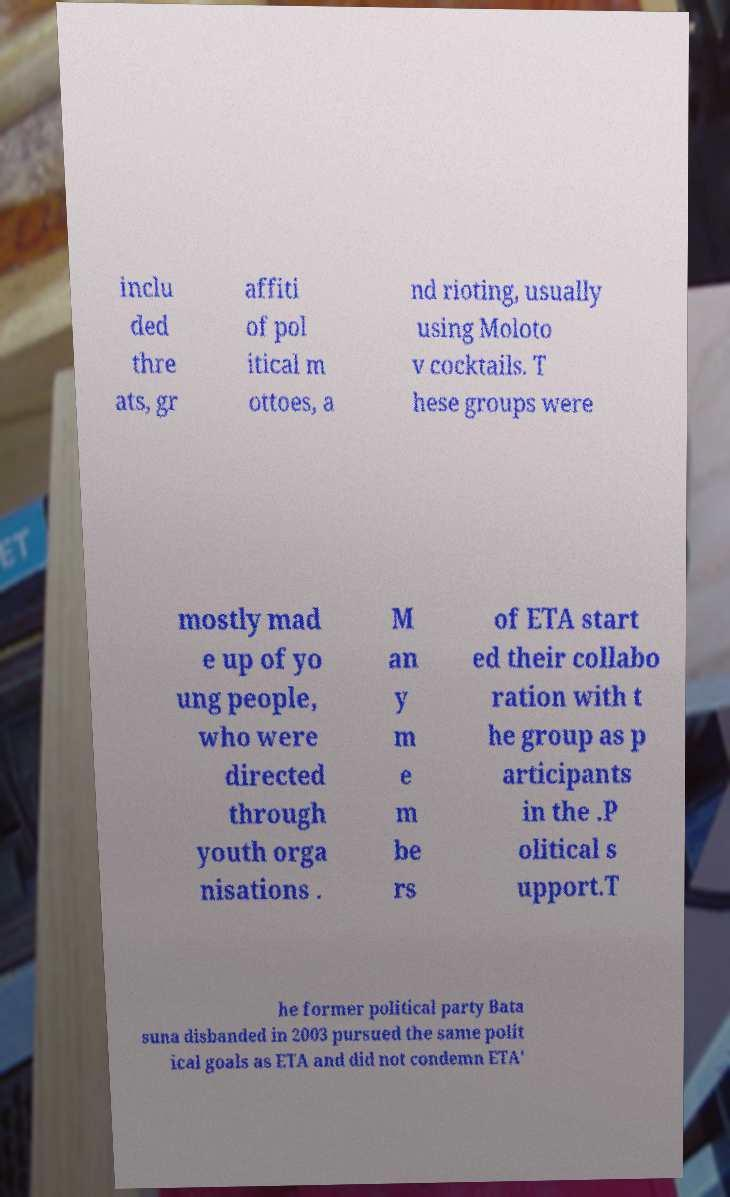Could you assist in decoding the text presented in this image and type it out clearly? inclu ded thre ats, gr affiti of pol itical m ottoes, a nd rioting, usually using Moloto v cocktails. T hese groups were mostly mad e up of yo ung people, who were directed through youth orga nisations . M an y m e m be rs of ETA start ed their collabo ration with t he group as p articipants in the .P olitical s upport.T he former political party Bata suna disbanded in 2003 pursued the same polit ical goals as ETA and did not condemn ETA' 